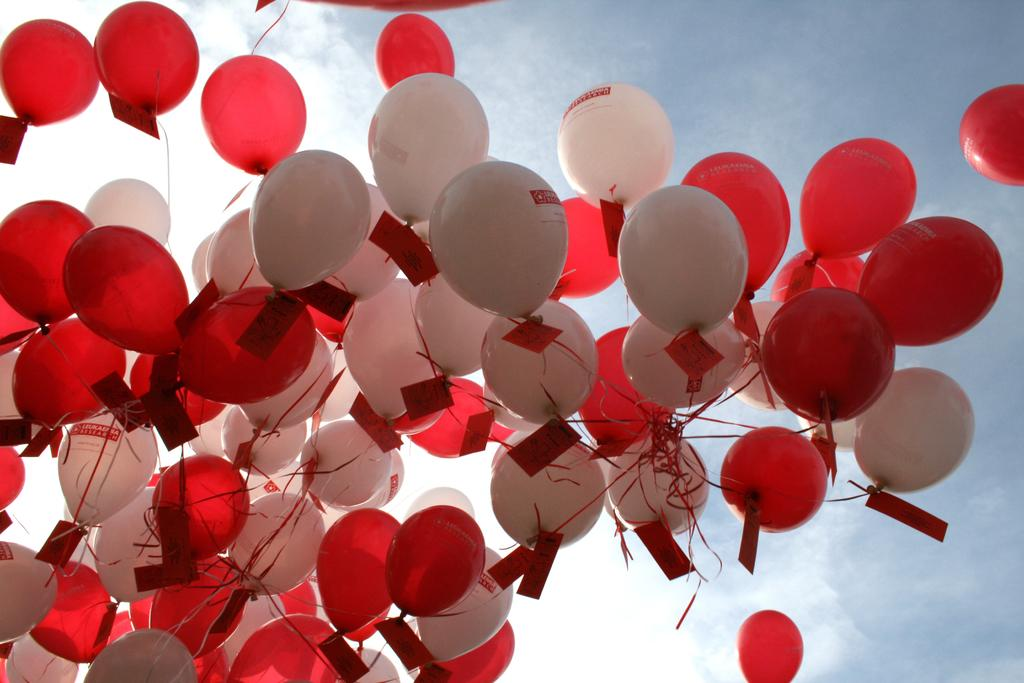What objects are present in the image? There are balloons in the image. What can be seen in the background of the image? The sky is visible in the background of the image. How many tickets are attached to the balloons in the image? There are no tickets present in the image; it only features balloons. 